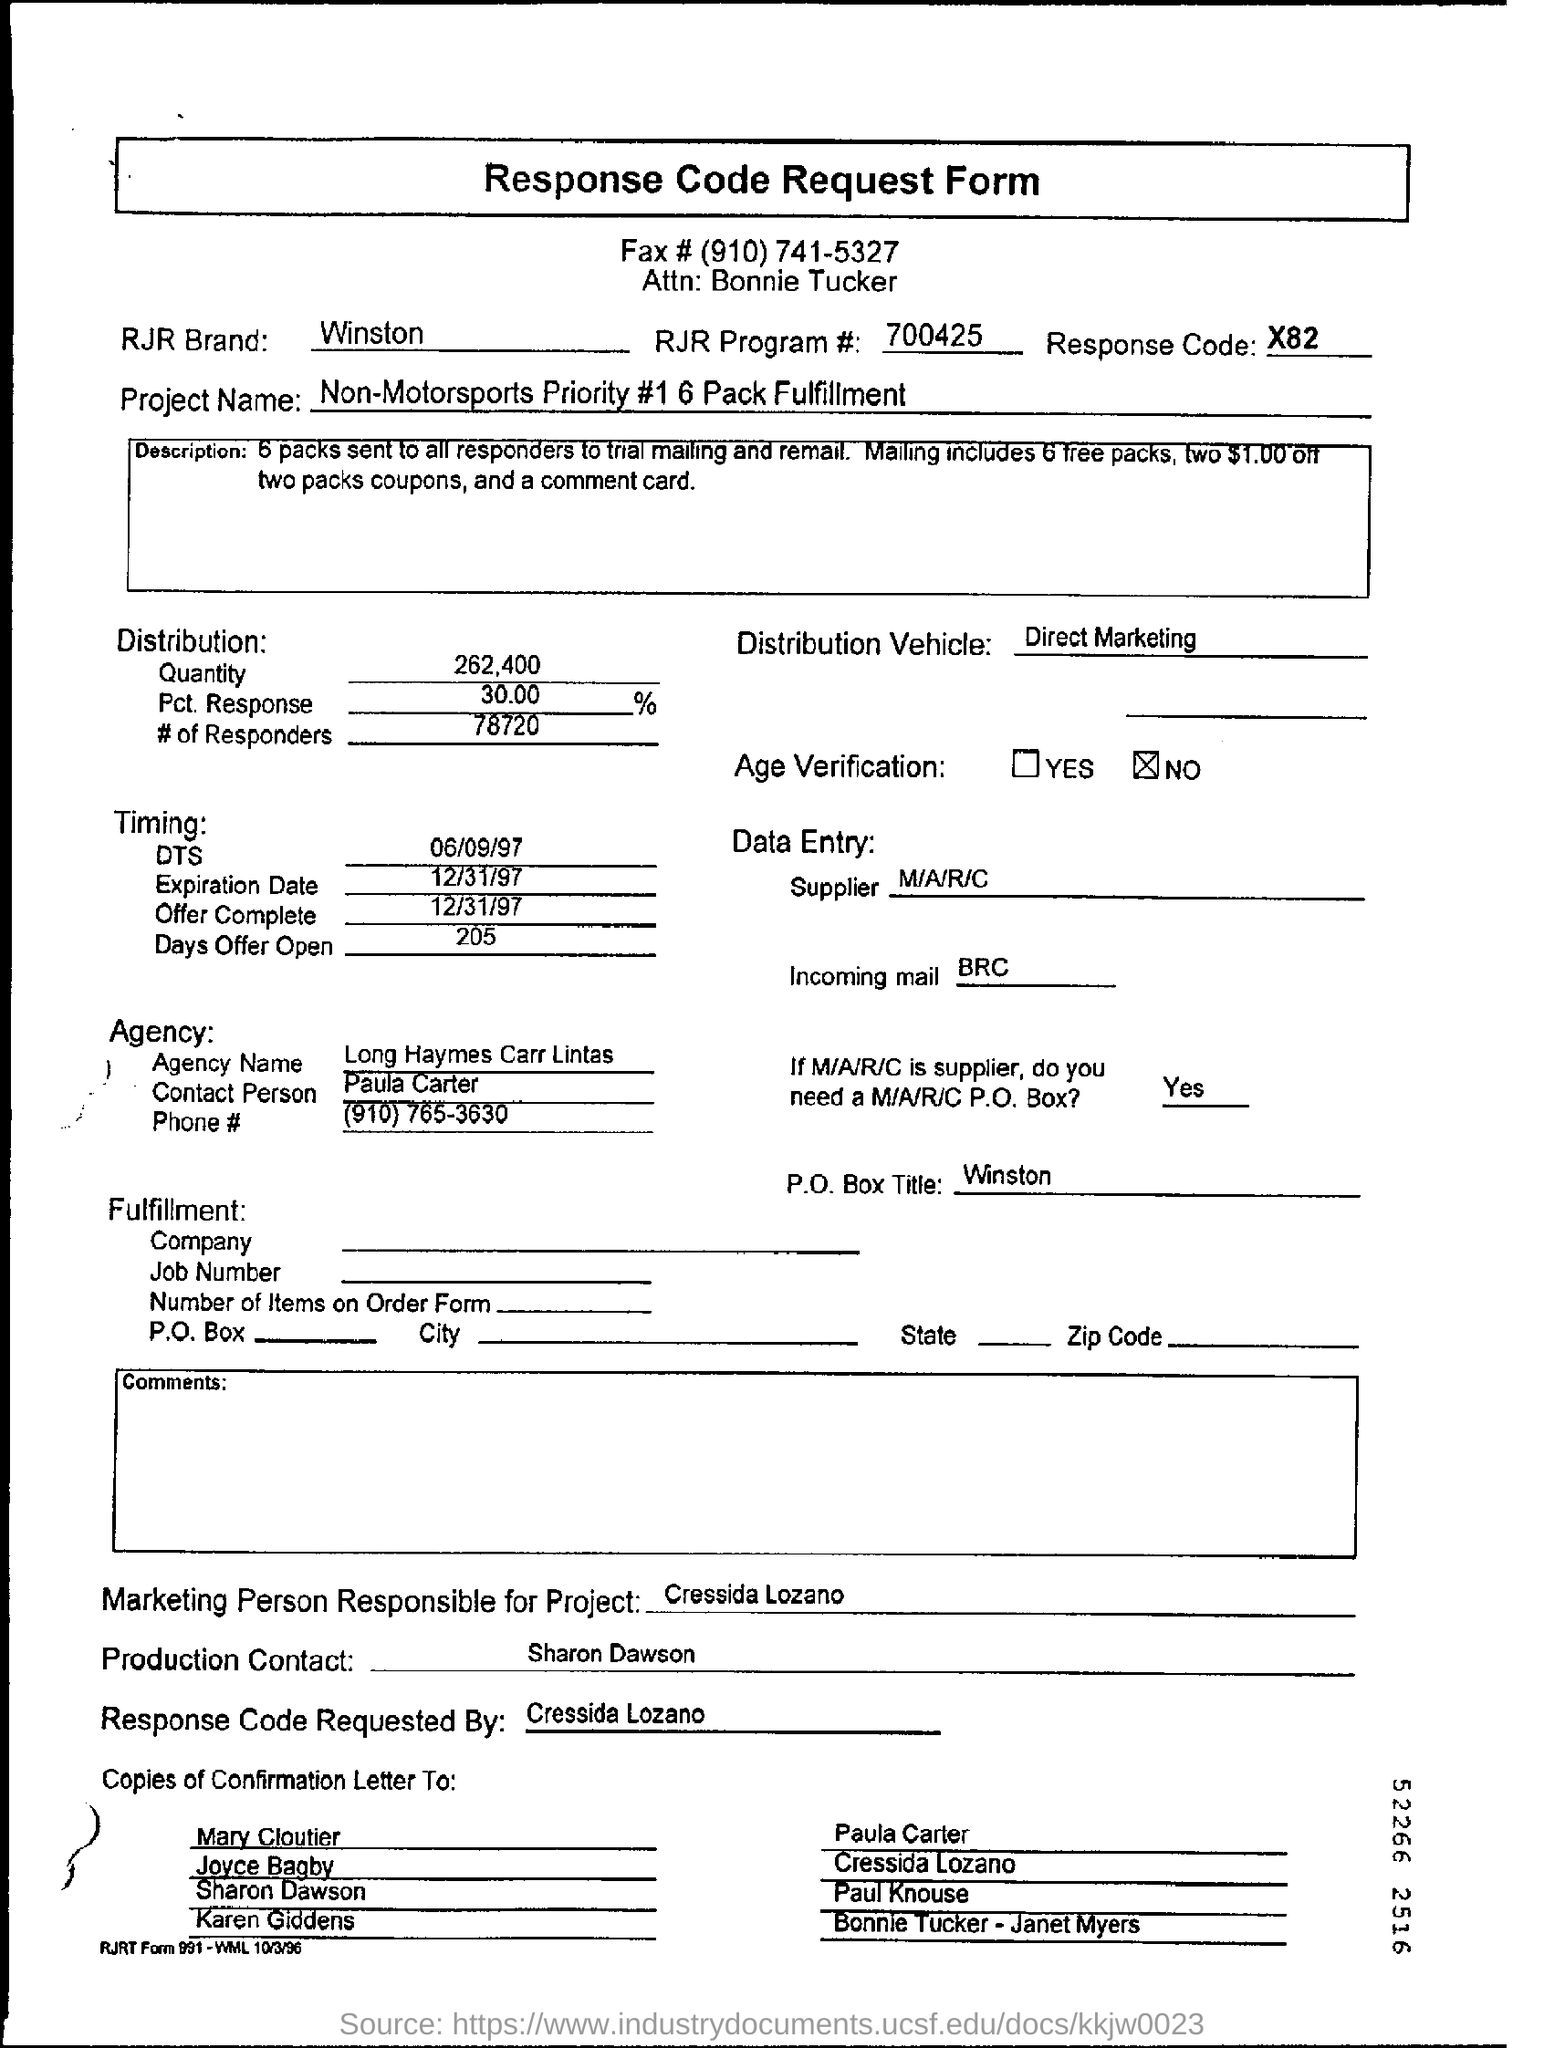Highlight a few significant elements in this photo. The RJR Program number is 700425. The P.O. Box title is Winston. The project name is "Non-Motorsports Priority #1 6 Pack Fulfillment". The Distribution Vehicle is a key component of Direct Marketing, which involves the use of various channels and strategies to distribute products or services directly to consumers, bypassing traditional intermediaries such as retailers. The contact person of the agency is Paula Carter. 